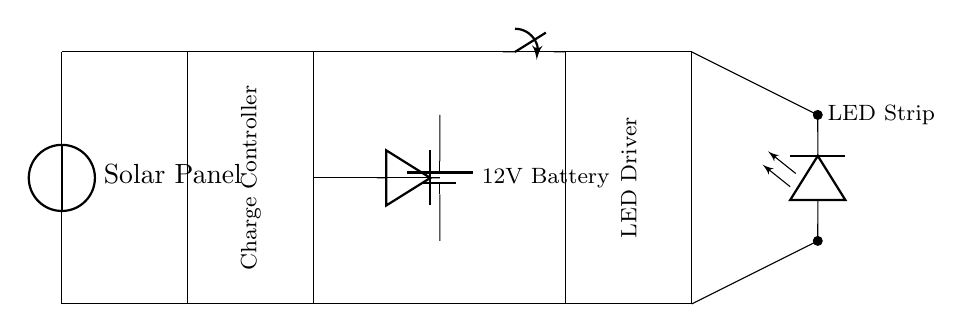What component converts solar energy to electrical energy? The solar panel in the circuit acts as a source, converting solar energy into electrical energy for the rest of the circuit.
Answer: Solar Panel What is the purpose of the charge controller? The charge controller manages the flow of electricity from the solar panel to the battery, ensuring proper charging and preventing overcharging.
Answer: Manage charging How many LEDs are in the LED strip? The LED strip appears to have multiple LEDs connected in series, but the exact number isn't specified in the diagram, as it might represent a long strip.
Answer: Multiple What is the voltage rating of the battery? The battery is indicated to have a voltage rating of twelve volts, which is essential for powering the LED driver and the LED strip.
Answer: 12V What is the role of the diode in this circuit? The diode allows current to flow in one direction only, preventing backflow from the battery to the solar panel when there is no sunlight.
Answer: Prevents backflow What is the function of the switch in the circuit? The switch can open or close the circuit, allowing users to turn the LED lighting system on or off as required.
Answer: Turn on/off What is the output voltage of the LED driver? While the exact output voltage isn't specified in the diagram, it is typically designed to provide a constant voltage suitable for the LED strip, likely around 12V to match the battery.
Answer: Suitable for LEDs 